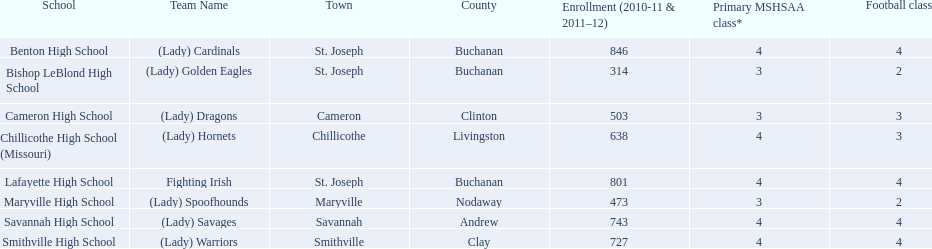What is the number of students attending each school? Benton High School, 846, Bishop LeBlond High School, 314, Cameron High School, 503, Chillicothe High School (Missouri), 638, Lafayette High School, 801, Maryville High School, 473, Savannah High School, 743, Smithville High School, 727. Which school offers no less than three football classes? Cameron High School, 3, Chillicothe High School (Missouri), 3. Which school has a total of 638 attending students and 3 football classes? Chillicothe High School (Missouri). 